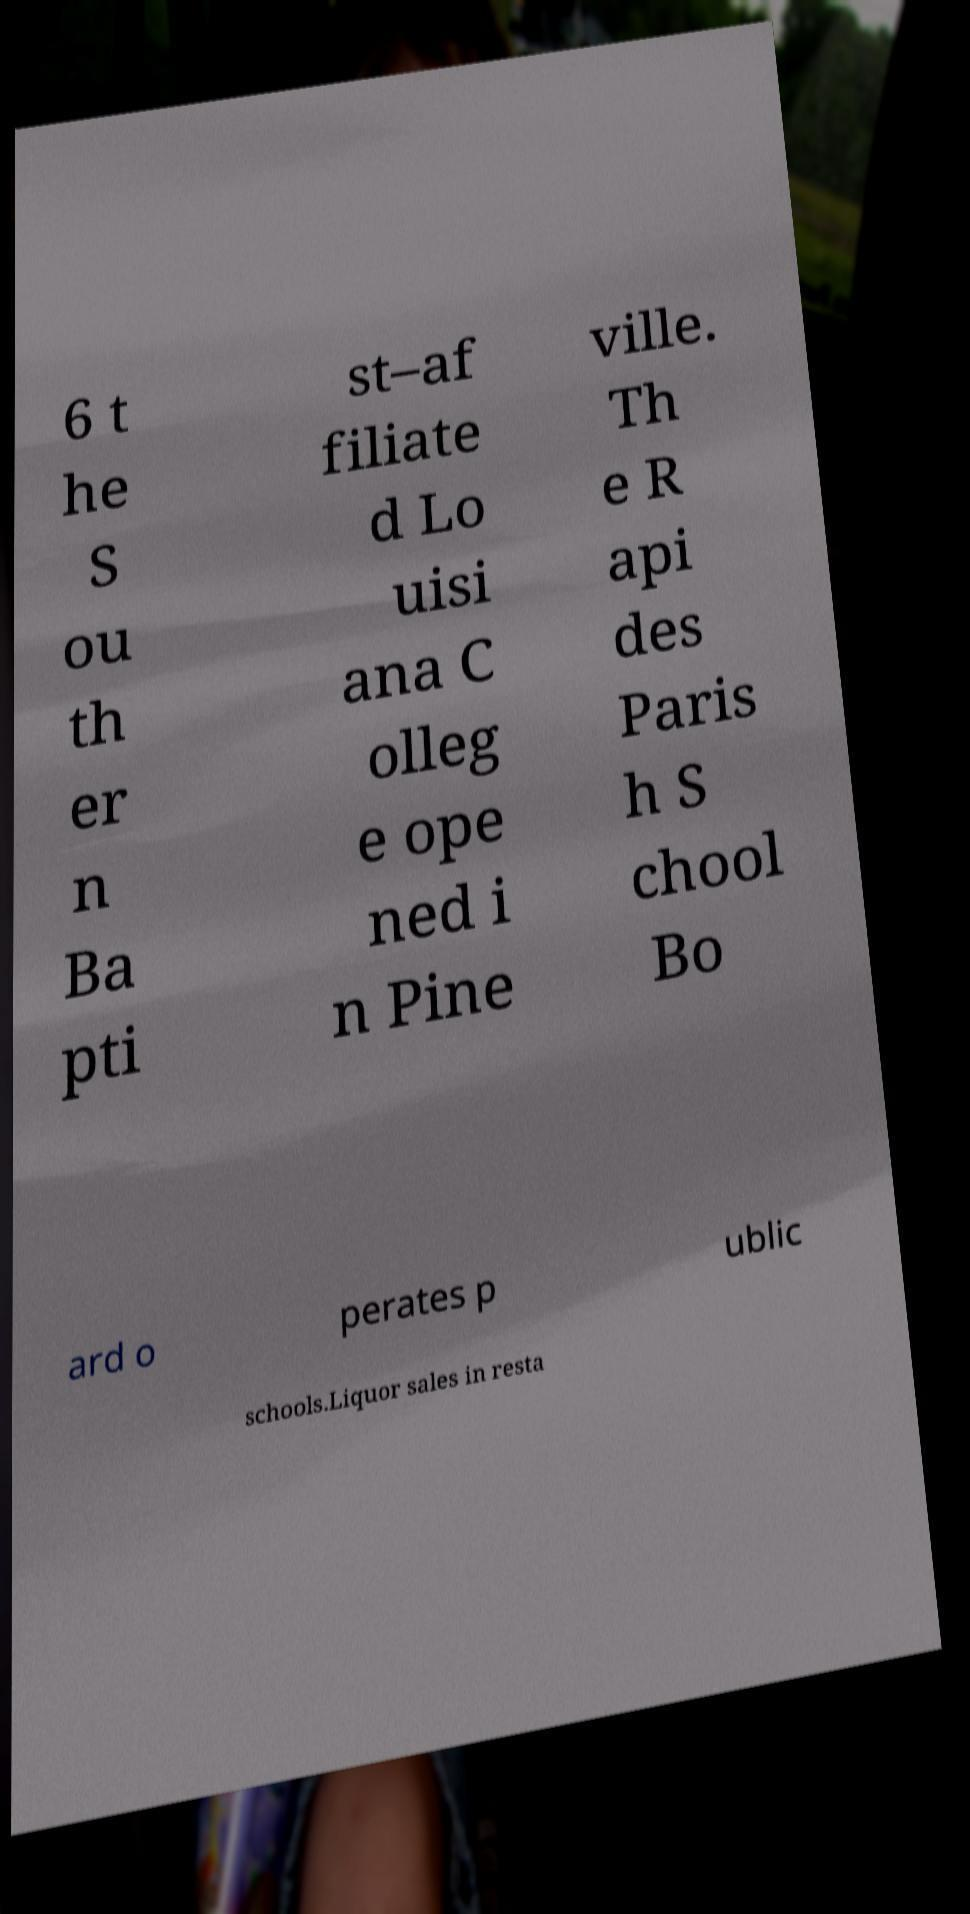What messages or text are displayed in this image? I need them in a readable, typed format. 6 t he S ou th er n Ba pti st–af filiate d Lo uisi ana C olleg e ope ned i n Pine ville. Th e R api des Paris h S chool Bo ard o perates p ublic schools.Liquor sales in resta 